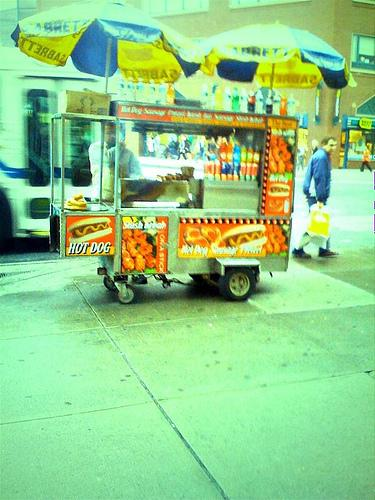What type of food is advertised on the cart?

Choices:
A) muffin
B) hot dog
C) hamburger
D) bagel hot dog 